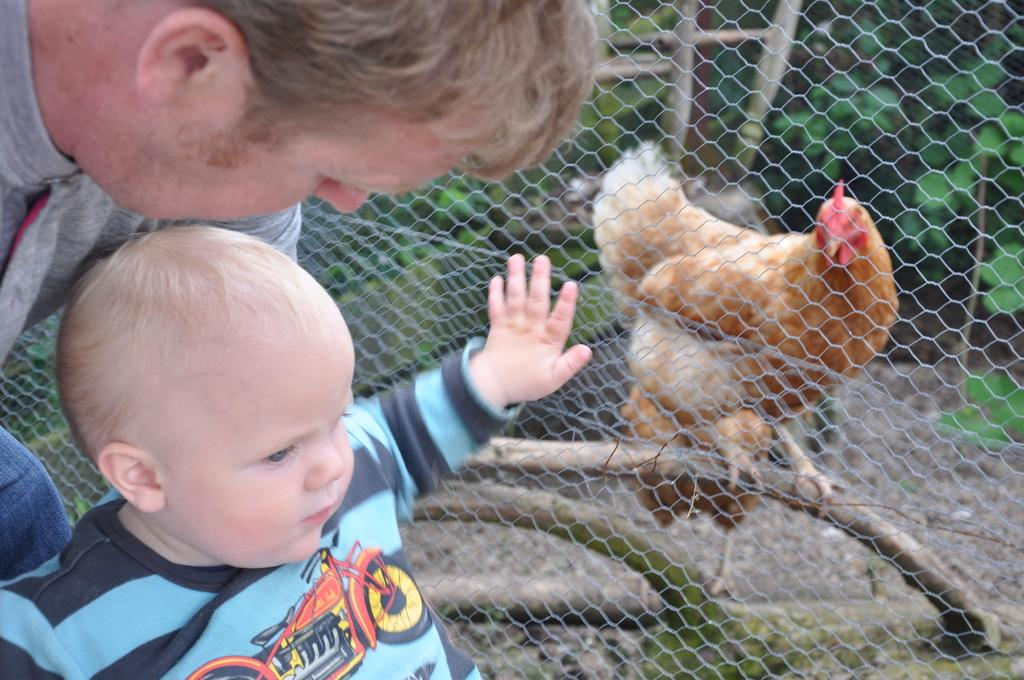Who is present in the image? There is a man and a baby in the image. Where are the man and baby located in the image? They are standing on the left side of the image. What can be seen in the background of the image? There is a net and a hen standing on a plant behind the net. What type of vegetation is present in the image? There are plants on the land in the image. What type of tax is being discussed in the image? There is no discussion of tax in the image; it features a man, a baby, a net, a hen, and plants. Can you see a toothbrush in the image? No, there is no toothbrush present in the image. 